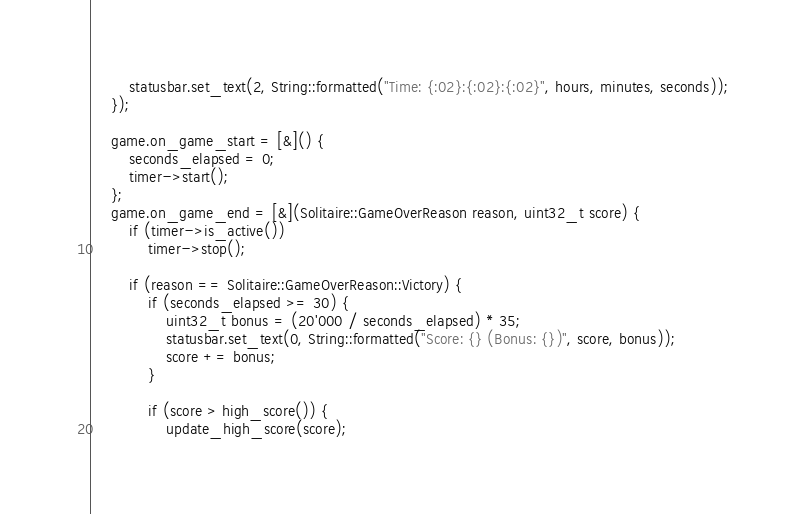<code> <loc_0><loc_0><loc_500><loc_500><_C++_>        statusbar.set_text(2, String::formatted("Time: {:02}:{:02}:{:02}", hours, minutes, seconds));
    });

    game.on_game_start = [&]() {
        seconds_elapsed = 0;
        timer->start();
    };
    game.on_game_end = [&](Solitaire::GameOverReason reason, uint32_t score) {
        if (timer->is_active())
            timer->stop();

        if (reason == Solitaire::GameOverReason::Victory) {
            if (seconds_elapsed >= 30) {
                uint32_t bonus = (20'000 / seconds_elapsed) * 35;
                statusbar.set_text(0, String::formatted("Score: {} (Bonus: {})", score, bonus));
                score += bonus;
            }

            if (score > high_score()) {
                update_high_score(score);</code> 